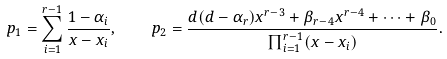Convert formula to latex. <formula><loc_0><loc_0><loc_500><loc_500>p _ { 1 } = \sum _ { i = 1 } ^ { r - 1 } \frac { 1 - \alpha _ { i } } { x - x _ { i } } , \quad p _ { 2 } = \frac { d ( d - \alpha _ { r } ) x ^ { r - 3 } + \beta _ { r - 4 } x ^ { r - 4 } + \cdots + \beta _ { 0 } } { \prod _ { i = 1 } ^ { r - 1 } ( x - x _ { i } ) } .</formula> 